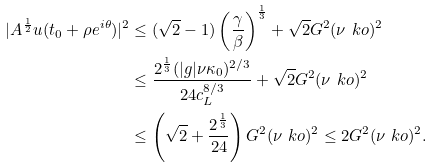Convert formula to latex. <formula><loc_0><loc_0><loc_500><loc_500>| A ^ { \frac { 1 } { 2 } } u ( t _ { 0 } + \rho e ^ { i \theta } ) | ^ { 2 } & \leq ( \sqrt { 2 } - 1 ) \left ( \frac { \gamma } { \beta } \right ) ^ { \frac { 1 } { 3 } } + \sqrt { 2 } G ^ { 2 } ( \nu \ k o ) ^ { 2 } \\ & \leq \frac { 2 ^ { \frac { 1 } { 3 } } ( | g | \nu \kappa _ { 0 } ) ^ { 2 / 3 } } { 2 4 c ^ { 8 / 3 } _ { L } } + \sqrt { 2 } G ^ { 2 } ( \nu \ k o ) ^ { 2 } \\ & \leq \left ( \sqrt { 2 } + \frac { 2 ^ { \frac { 1 } { 3 } } } { 2 4 } \right ) G ^ { 2 } ( \nu \ k o ) ^ { 2 } \leq 2 G ^ { 2 } ( \nu \ k o ) ^ { 2 } .</formula> 